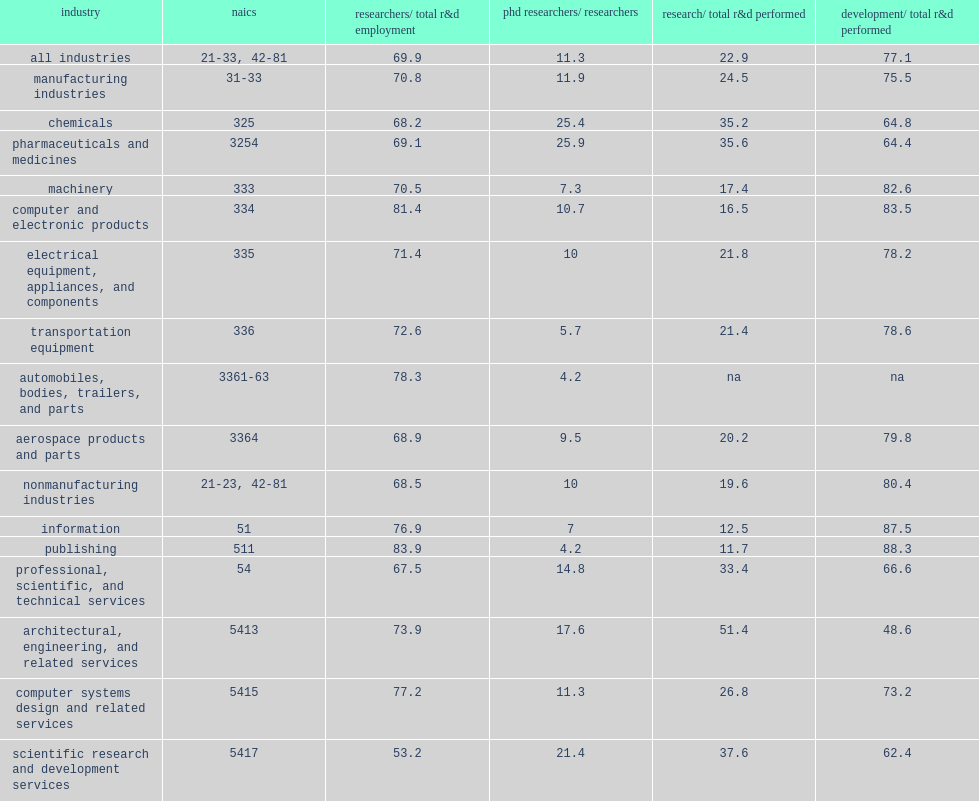Across all industries, how many percent of r&d workers did researchers account for? 69.9. Across all industries, how many percent of phd r&d workers did researchers account for? 11.3. In terms of type of r&d, how many percent are most business u.s. r&d expenditures concentrated in development activities? 77.1. How many percent of the pharmaceuticals and medicine manufacturing industries which had the largest shares of phds researchers relative to their industry's total researchers among 4-digit industries employing 5,000 or more phd researchers? 25.9. How many percent of the scientific r&d services industries had the largest shares of phds researchers relative to their industry's total researchers among 4-digit industries employing 5,000 or more phd researchers? 21.4. How many percent of the pharmaceuticals and medicine manufacturing industries which had large shares of research relative to total r&d expenditures? 35.6. How many percent of the scientific r&d services industries which had large shares of research relative to total r&d expenditures? 37.6. How many percent of the pharmaceuticals and medicine manufacturing industries which had large shares of research relative to total r&d expenditures? 22.9. 